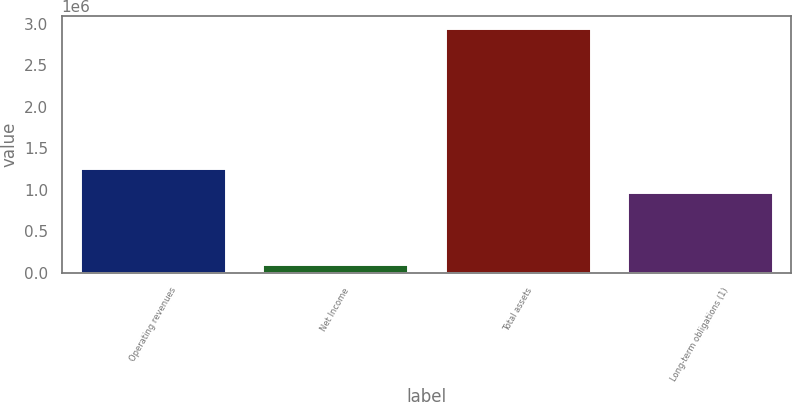Convert chart to OTSL. <chart><loc_0><loc_0><loc_500><loc_500><bar_chart><fcel>Operating revenues<fcel>Net Income<fcel>Total assets<fcel>Long-term obligations (1)<nl><fcel>1.26647e+06<fcel>108729<fcel>2.94339e+06<fcel>978932<nl></chart> 